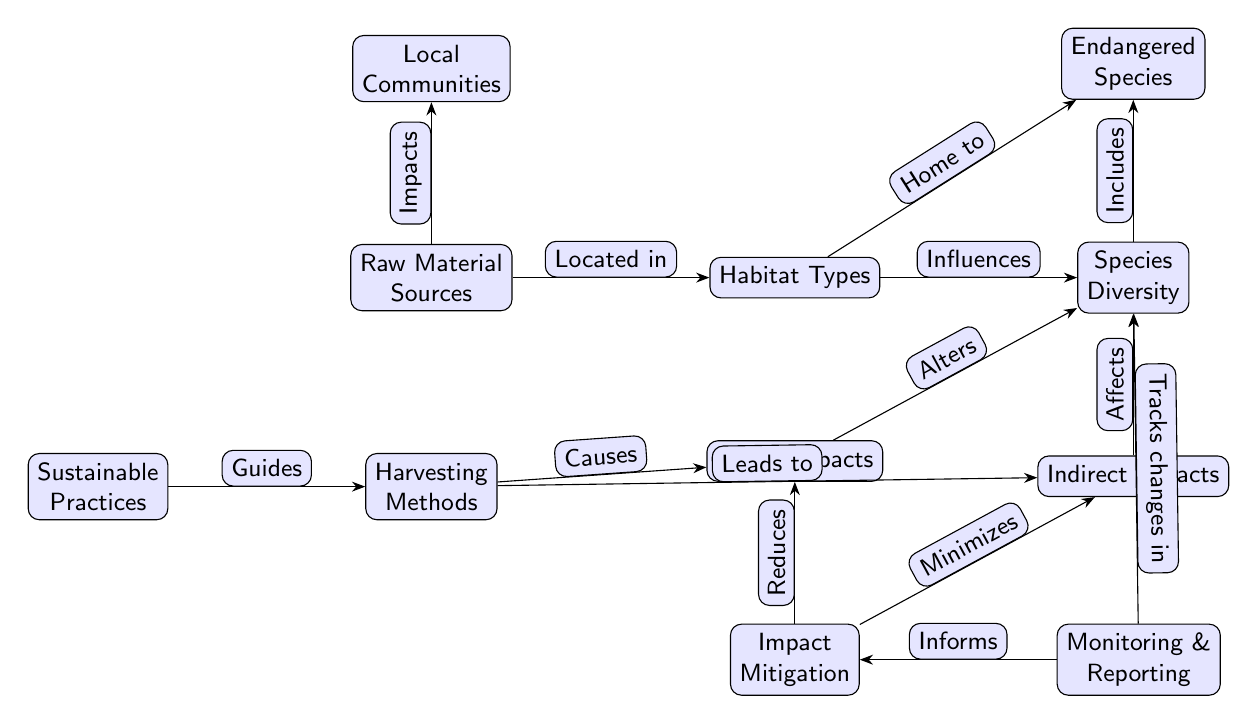What are the two main categories of impacts caused by harvesting methods? The diagram illustrates that harvesting methods lead to both direct impacts and indirect impacts as seen in the nodes directly below the Raw Material Sources and Species Diversity nodes.
Answer: Direct Impacts, Indirect Impacts Which node is connected to the Endangered Species? The diagram shows that Endangered Species is connected to both Species Diversity and Habitat Types, indicating that these nodes have a relationship with endangered species.
Answer: Species Diversity, Habitat Types What does Impact Mitigation reduce? The diagram specifies that Impact Mitigation reduces Direct Impacts, as denoted by the edge labeled "Reduces" leading from Impact Mitigation to Direct Impacts.
Answer: Direct Impacts How many nodes are there for community-related elements in the diagram? By examining the diagram, one can see there is only one node that represents community impact, which is the Local Communities node, positioned above Raw Material Sources.
Answer: 1 What is the relationship between Habitat Types and Species Diversity? The diagram indicates that Habitat Types influences Species Diversity, as represented by the edge that connects the two nodes with the label "Influences."
Answer: Influences Which node demonstrates the guidance of harvesting methods? The diagram shows that Sustainable Practices is the node that guides Harvesting Methods, indicated by the edge labeled "Guides" between the two nodes.
Answer: Sustainable Practices What does Monitoring track changes in? The Monitoring node is connected to Species Diversity with the edge labeled "Tracks changes in," directly stating what the monitoring process focuses on tracking.
Answer: Species Diversity How does Sustainable Practices influence harvesting methods? The diagram shows that Sustainable Practices guides Harvesting Methods, which implies that certain practices are meant to improve or inform the methods of harvesting.
Answer: Guides Which aspect do Direct Impacts and Indirect Impacts affect? The diagram indicates that both Direct and Indirect Impacts alter Species Diversity, as shown by the edges leading from both impact nodes to the Species Diversity node.
Answer: Species Diversity 